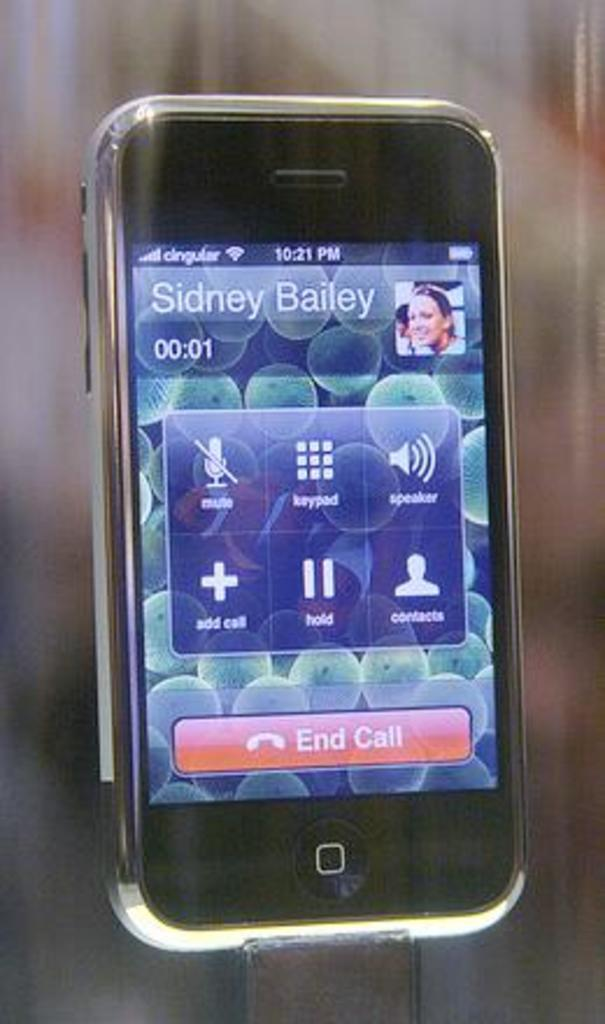<image>
Offer a succinct explanation of the picture presented. a phone making a call to sidney bailey 